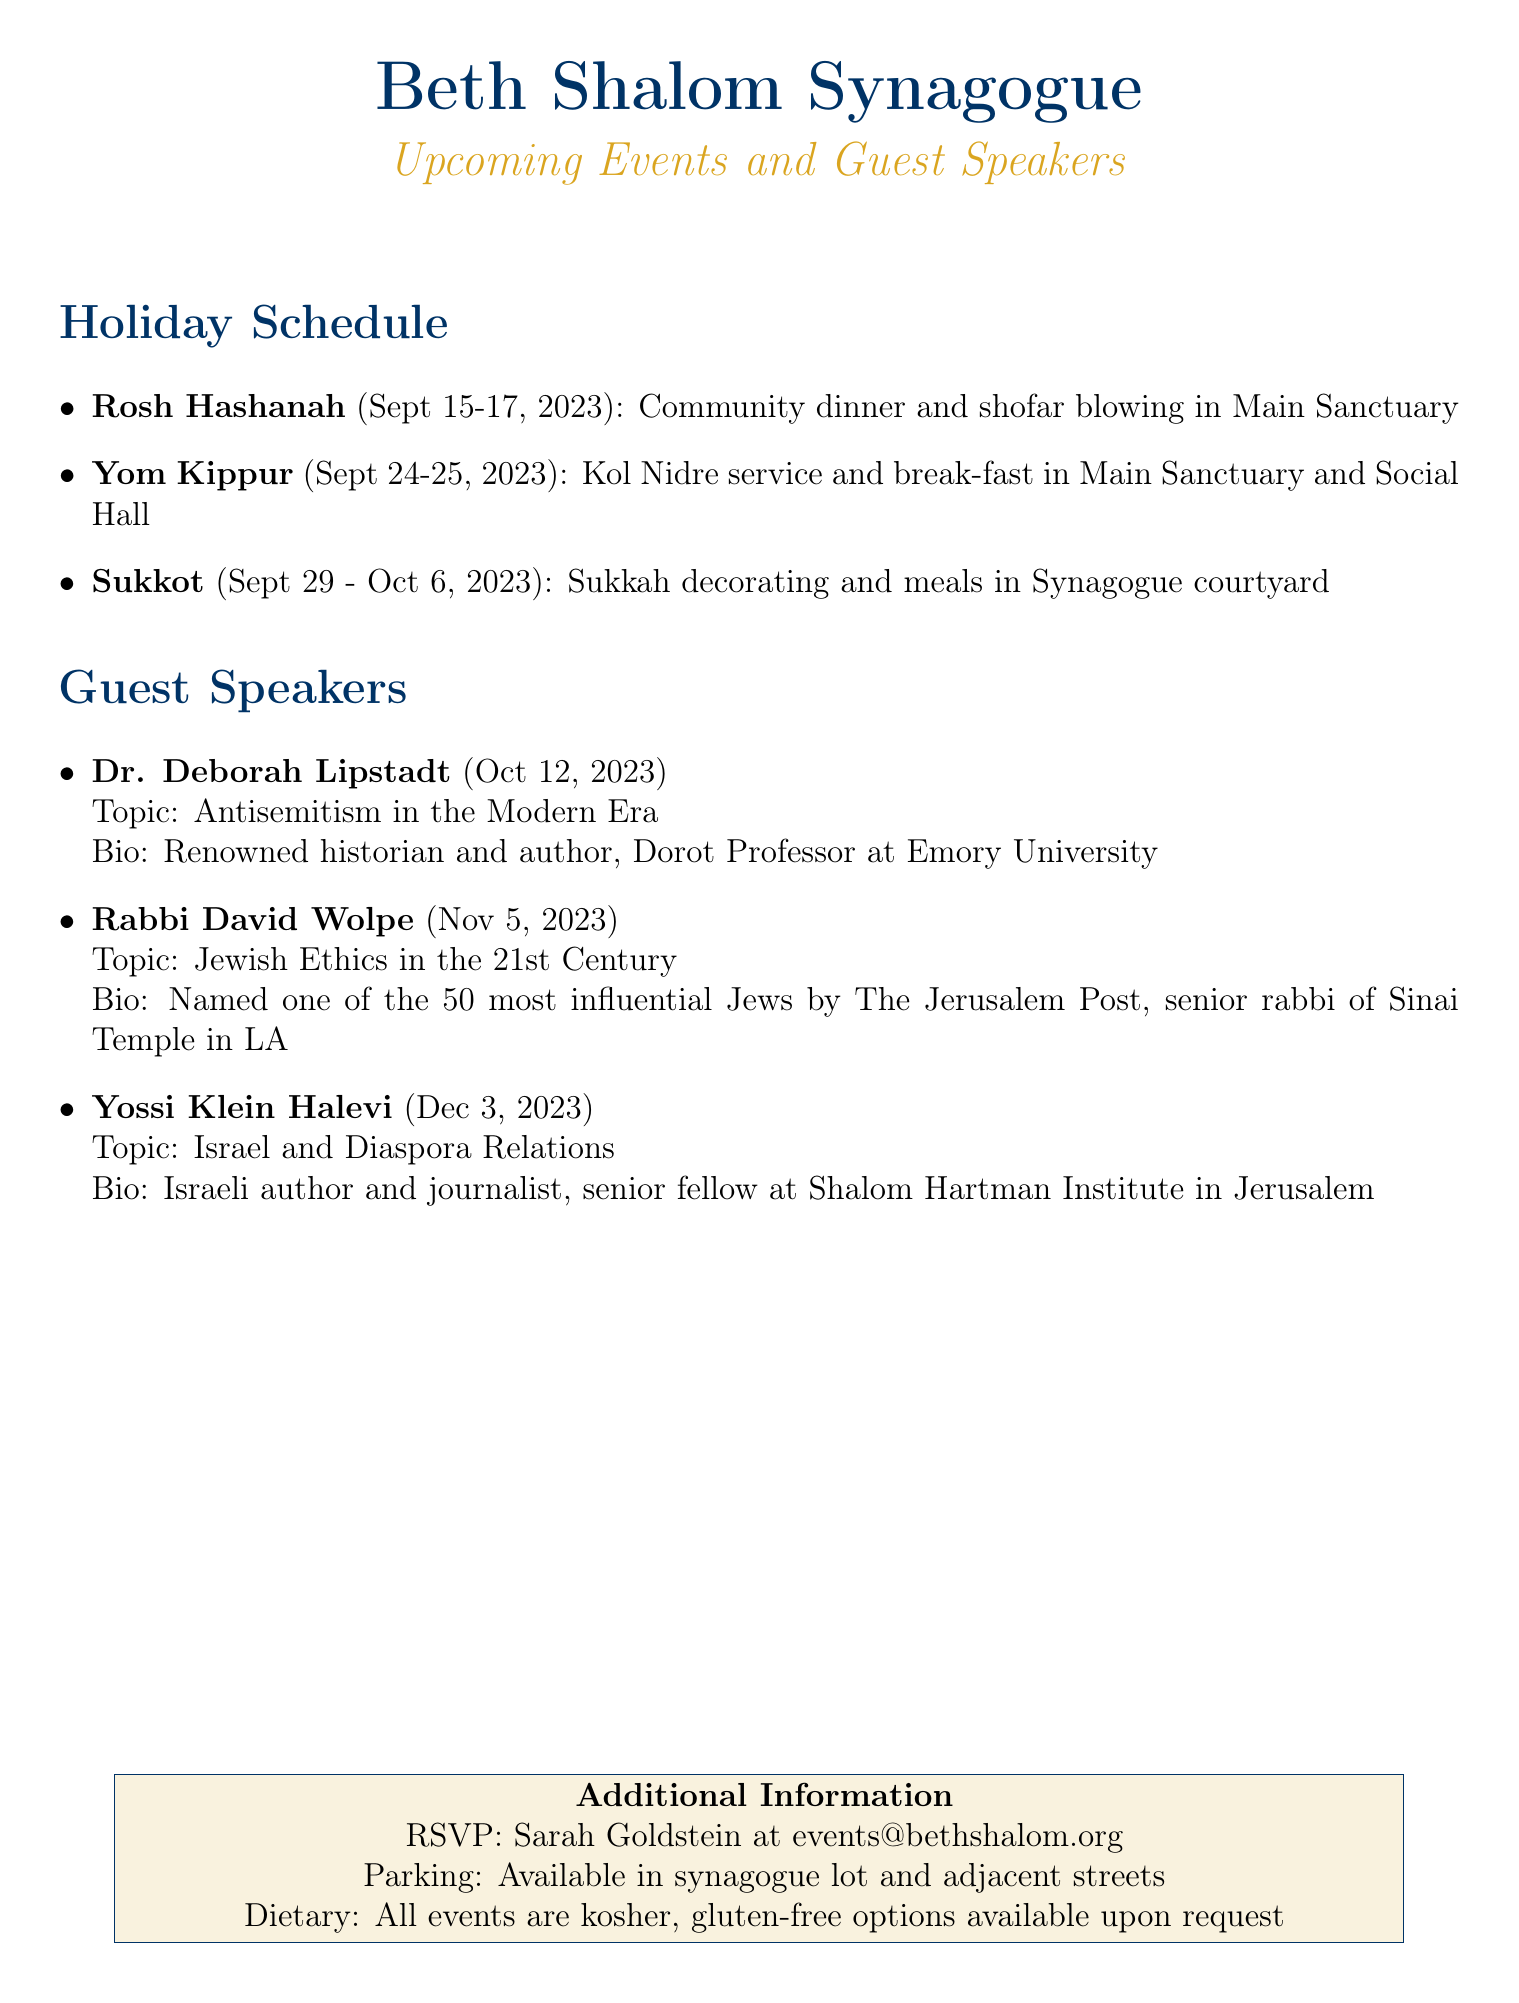What is the date for Rosh Hashanah? Rosh Hashanah is scheduled for September 15-17, 2023.
Answer: September 15-17, 2023 What is the main event for Yom Kippur? The main event for Yom Kippur is the Kol Nidre service and break-fast.
Answer: Kol Nidre service and break-fast Who is the guest speaker on November 5, 2023? On November 5, 2023, Rabbi David Wolpe will be the guest speaker.
Answer: Rabbi David Wolpe What is Dr. Deborah Lipstadt's topic? Dr. Deborah Lipstadt will speak on Antisemitism in the Modern Era.
Answer: Antisemitism in the Modern Era Where will the Sukkah decorating event take place? The Sukkah decorating event will take place in the synagogue courtyard.
Answer: Synagogue courtyard What type of dietary accommodations are available? All events are kosher, with gluten-free options available upon request.
Answer: Kosher, gluten-free options How can someone RSVP for an event? RSVP can be made by contacting Sarah Goldstein at events@bethshalom.org.
Answer: Sarah Goldstein at events@bethshalom.org What is the bio of Yossi Klein Halevi? Yossi Klein Halevi is an Israeli author and journalist, senior fellow at the Shalom Hartman Institute in Jerusalem.
Answer: Israeli author and journalist, senior fellow at Shalom Hartman Institute in Jerusalem What is the location for the Kol Nidre service? The Kol Nidre service will be held in the Main Sanctuary and Social Hall.
Answer: Main Sanctuary and Social Hall 